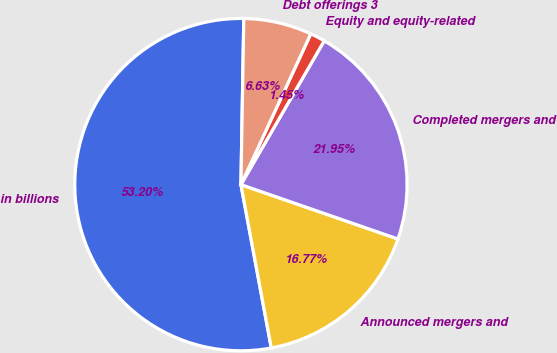Convert chart. <chart><loc_0><loc_0><loc_500><loc_500><pie_chart><fcel>in billions<fcel>Announced mergers and<fcel>Completed mergers and<fcel>Equity and equity-related<fcel>Debt offerings 3<nl><fcel>53.2%<fcel>16.77%<fcel>21.95%<fcel>1.45%<fcel>6.63%<nl></chart> 